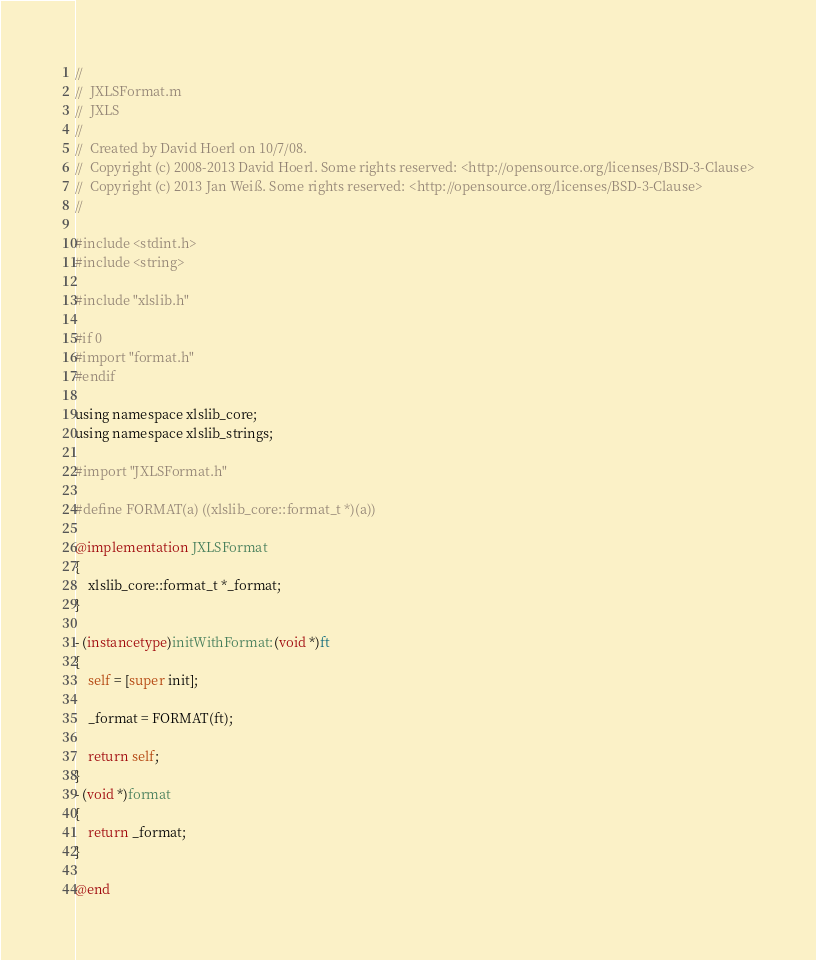Convert code to text. <code><loc_0><loc_0><loc_500><loc_500><_ObjectiveC_>//
//  JXLSFormat.m
//  JXLS
//
//  Created by David Hoerl on 10/7/08.
//  Copyright (c) 2008-2013 David Hoerl. Some rights reserved: <http://opensource.org/licenses/BSD-3-Clause>
//  Copyright (c) 2013 Jan Weiß. Some rights reserved: <http://opensource.org/licenses/BSD-3-Clause>
//

#include <stdint.h>
#include <string>

#include "xlslib.h"

#if 0
#import "format.h"
#endif

using namespace xlslib_core;
using namespace xlslib_strings;

#import "JXLSFormat.h"

#define FORMAT(a) ((xlslib_core::format_t *)(a))

@implementation JXLSFormat
{
	xlslib_core::format_t *_format;
}

- (instancetype)initWithFormat:(void *)ft
{
	self = [super init];
	
	_format = FORMAT(ft);
	
	return self;
}
- (void *)format
{
	return _format;
}

@end
</code> 